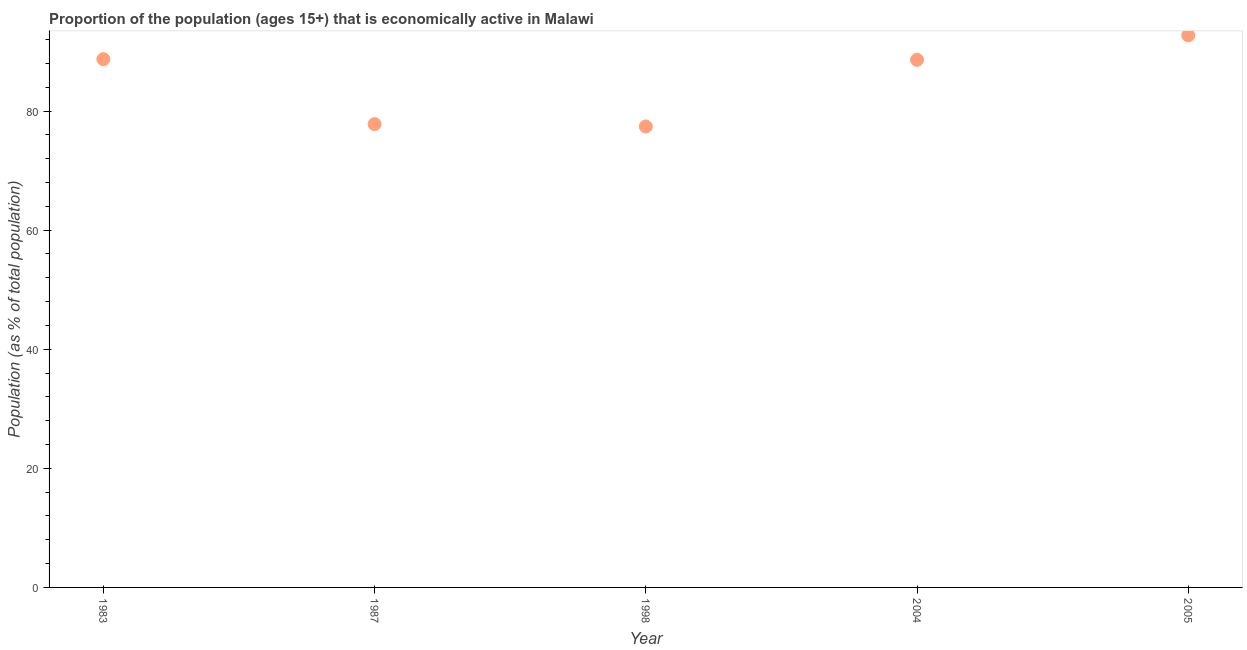What is the percentage of economically active population in 2004?
Provide a succinct answer. 88.6. Across all years, what is the maximum percentage of economically active population?
Keep it short and to the point. 92.7. Across all years, what is the minimum percentage of economically active population?
Ensure brevity in your answer.  77.4. In which year was the percentage of economically active population maximum?
Provide a short and direct response. 2005. In which year was the percentage of economically active population minimum?
Your answer should be very brief. 1998. What is the sum of the percentage of economically active population?
Your response must be concise. 425.2. What is the difference between the percentage of economically active population in 1983 and 1998?
Keep it short and to the point. 11.3. What is the average percentage of economically active population per year?
Your answer should be compact. 85.04. What is the median percentage of economically active population?
Offer a terse response. 88.6. In how many years, is the percentage of economically active population greater than 4 %?
Your answer should be compact. 5. What is the ratio of the percentage of economically active population in 1983 to that in 2004?
Your answer should be very brief. 1. Is the difference between the percentage of economically active population in 1983 and 1998 greater than the difference between any two years?
Offer a terse response. No. What is the difference between the highest and the second highest percentage of economically active population?
Keep it short and to the point. 4. What is the difference between the highest and the lowest percentage of economically active population?
Provide a short and direct response. 15.3. How many dotlines are there?
Ensure brevity in your answer.  1. Are the values on the major ticks of Y-axis written in scientific E-notation?
Offer a terse response. No. Does the graph contain any zero values?
Provide a succinct answer. No. Does the graph contain grids?
Provide a short and direct response. No. What is the title of the graph?
Provide a succinct answer. Proportion of the population (ages 15+) that is economically active in Malawi. What is the label or title of the Y-axis?
Keep it short and to the point. Population (as % of total population). What is the Population (as % of total population) in 1983?
Provide a short and direct response. 88.7. What is the Population (as % of total population) in 1987?
Ensure brevity in your answer.  77.8. What is the Population (as % of total population) in 1998?
Keep it short and to the point. 77.4. What is the Population (as % of total population) in 2004?
Provide a succinct answer. 88.6. What is the Population (as % of total population) in 2005?
Your response must be concise. 92.7. What is the difference between the Population (as % of total population) in 1983 and 1987?
Ensure brevity in your answer.  10.9. What is the difference between the Population (as % of total population) in 1983 and 2004?
Your answer should be very brief. 0.1. What is the difference between the Population (as % of total population) in 1987 and 2004?
Offer a very short reply. -10.8. What is the difference between the Population (as % of total population) in 1987 and 2005?
Offer a very short reply. -14.9. What is the difference between the Population (as % of total population) in 1998 and 2005?
Offer a very short reply. -15.3. What is the ratio of the Population (as % of total population) in 1983 to that in 1987?
Provide a short and direct response. 1.14. What is the ratio of the Population (as % of total population) in 1983 to that in 1998?
Offer a terse response. 1.15. What is the ratio of the Population (as % of total population) in 1983 to that in 2004?
Offer a very short reply. 1. What is the ratio of the Population (as % of total population) in 1983 to that in 2005?
Offer a terse response. 0.96. What is the ratio of the Population (as % of total population) in 1987 to that in 1998?
Provide a succinct answer. 1. What is the ratio of the Population (as % of total population) in 1987 to that in 2004?
Your answer should be compact. 0.88. What is the ratio of the Population (as % of total population) in 1987 to that in 2005?
Your response must be concise. 0.84. What is the ratio of the Population (as % of total population) in 1998 to that in 2004?
Provide a short and direct response. 0.87. What is the ratio of the Population (as % of total population) in 1998 to that in 2005?
Offer a very short reply. 0.83. What is the ratio of the Population (as % of total population) in 2004 to that in 2005?
Ensure brevity in your answer.  0.96. 